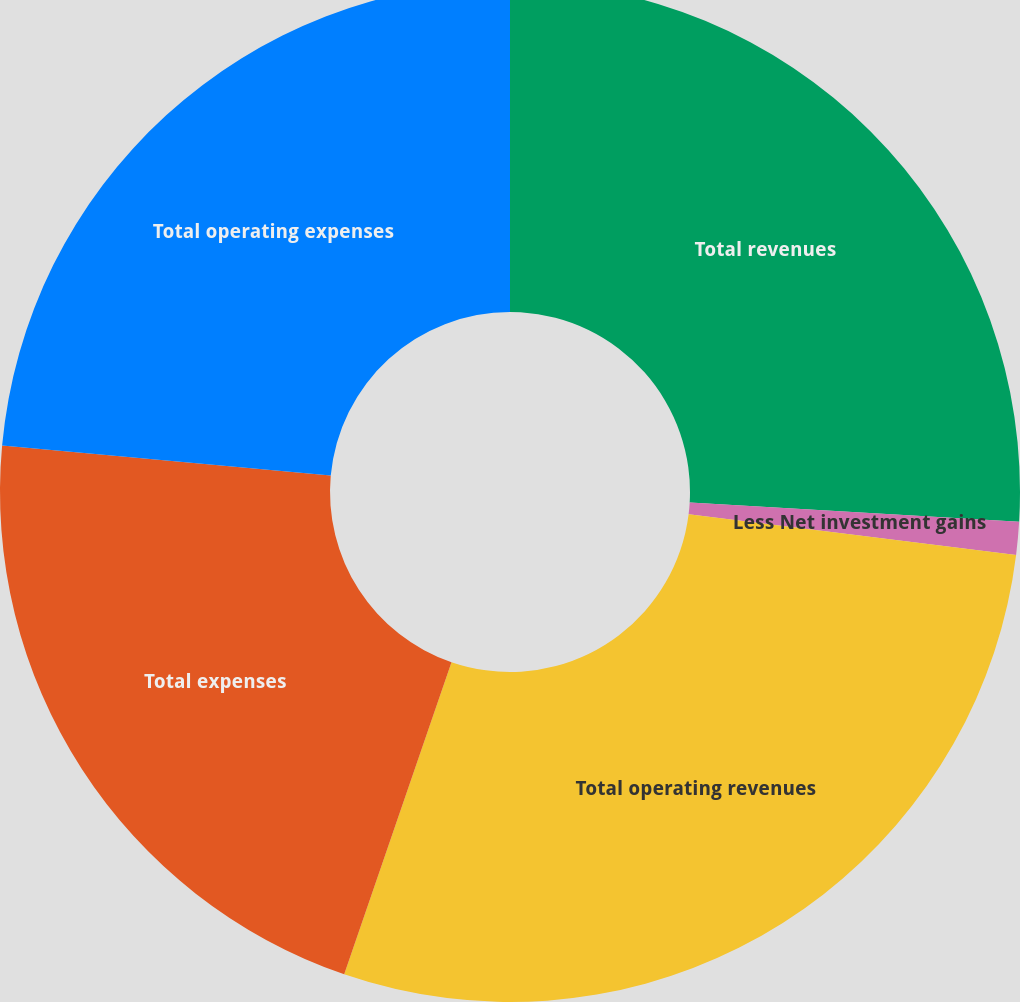Convert chart. <chart><loc_0><loc_0><loc_500><loc_500><pie_chart><fcel>Total revenues<fcel>Less Net investment gains<fcel>Total operating revenues<fcel>Total expenses<fcel>Total operating expenses<nl><fcel>25.93%<fcel>1.04%<fcel>28.3%<fcel>21.18%<fcel>23.55%<nl></chart> 